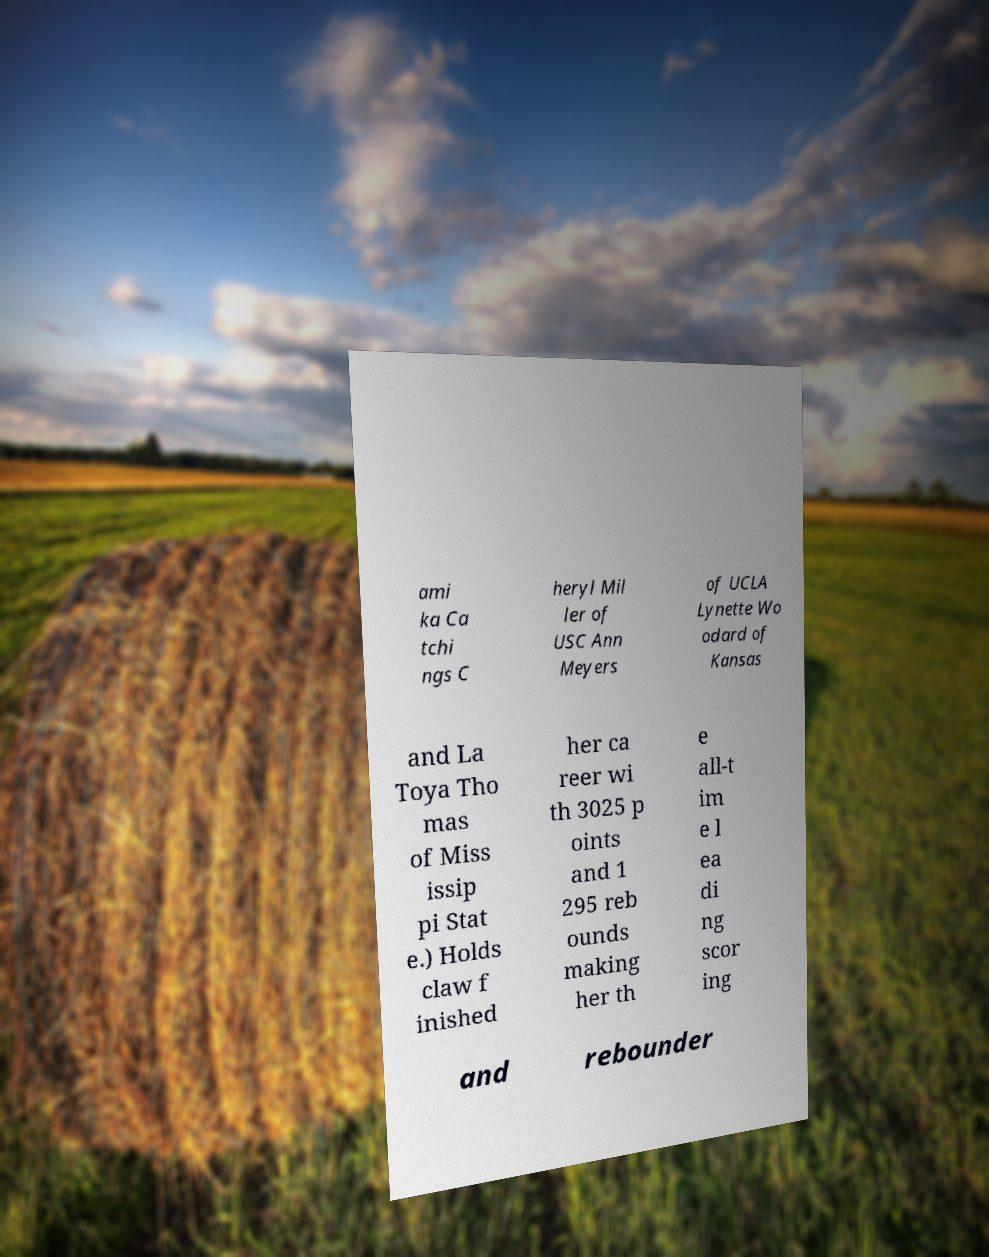Can you read and provide the text displayed in the image?This photo seems to have some interesting text. Can you extract and type it out for me? ami ka Ca tchi ngs C heryl Mil ler of USC Ann Meyers of UCLA Lynette Wo odard of Kansas and La Toya Tho mas of Miss issip pi Stat e.) Holds claw f inished her ca reer wi th 3025 p oints and 1 295 reb ounds making her th e all-t im e l ea di ng scor ing and rebounder 